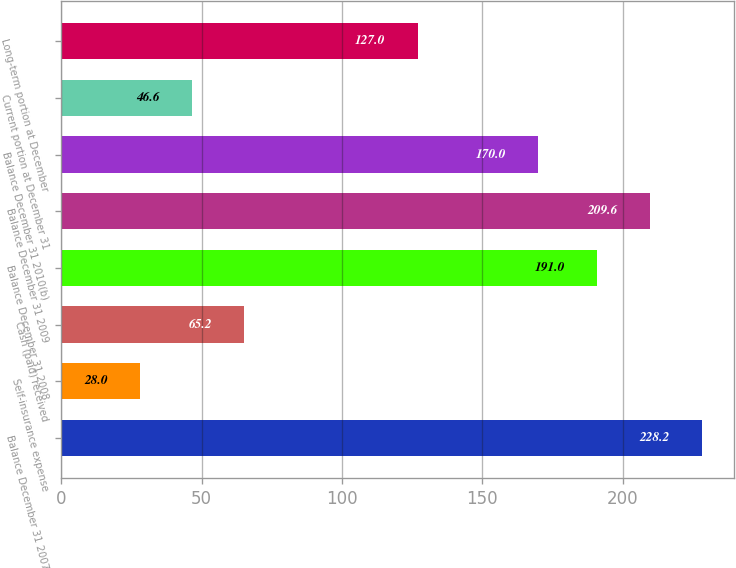Convert chart to OTSL. <chart><loc_0><loc_0><loc_500><loc_500><bar_chart><fcel>Balance December 31 2007<fcel>Self-insurance expense<fcel>Cash (paid) received<fcel>Balance December 31 2008<fcel>Balance December 31 2009<fcel>Balance December 31 2010(b)<fcel>Current portion at December 31<fcel>Long-term portion at December<nl><fcel>228.2<fcel>28<fcel>65.2<fcel>191<fcel>209.6<fcel>170<fcel>46.6<fcel>127<nl></chart> 